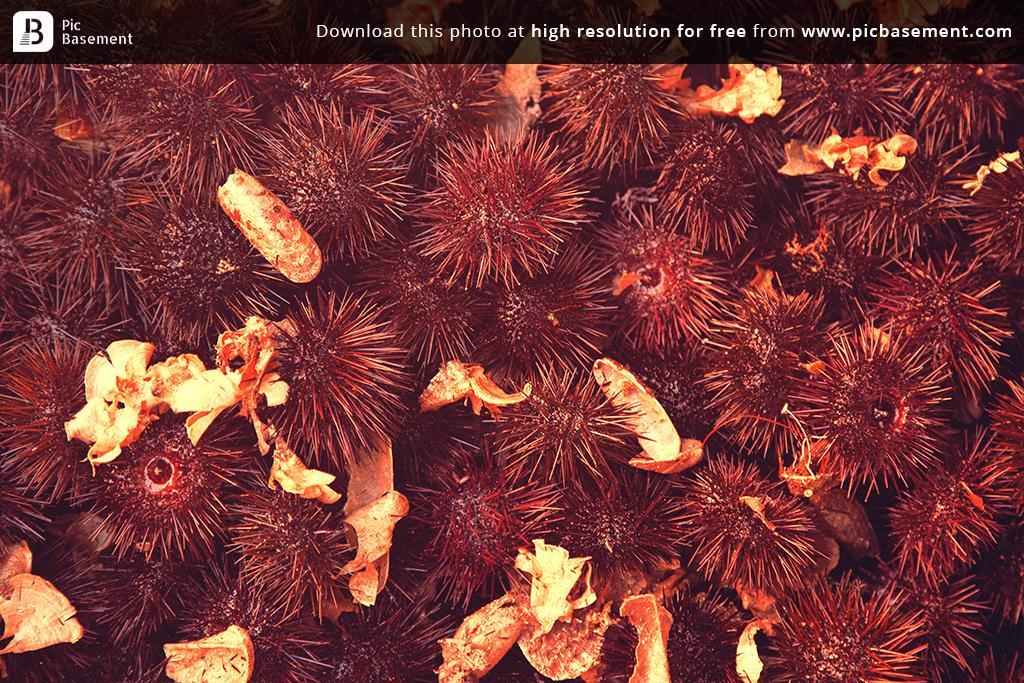Describe this image in one or two sentences. In this image we can see flowers. Top of the image watermark is present. 